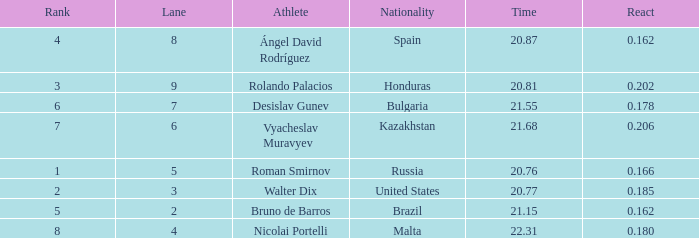What's Russia's lane when they were ranked before 1? None. 